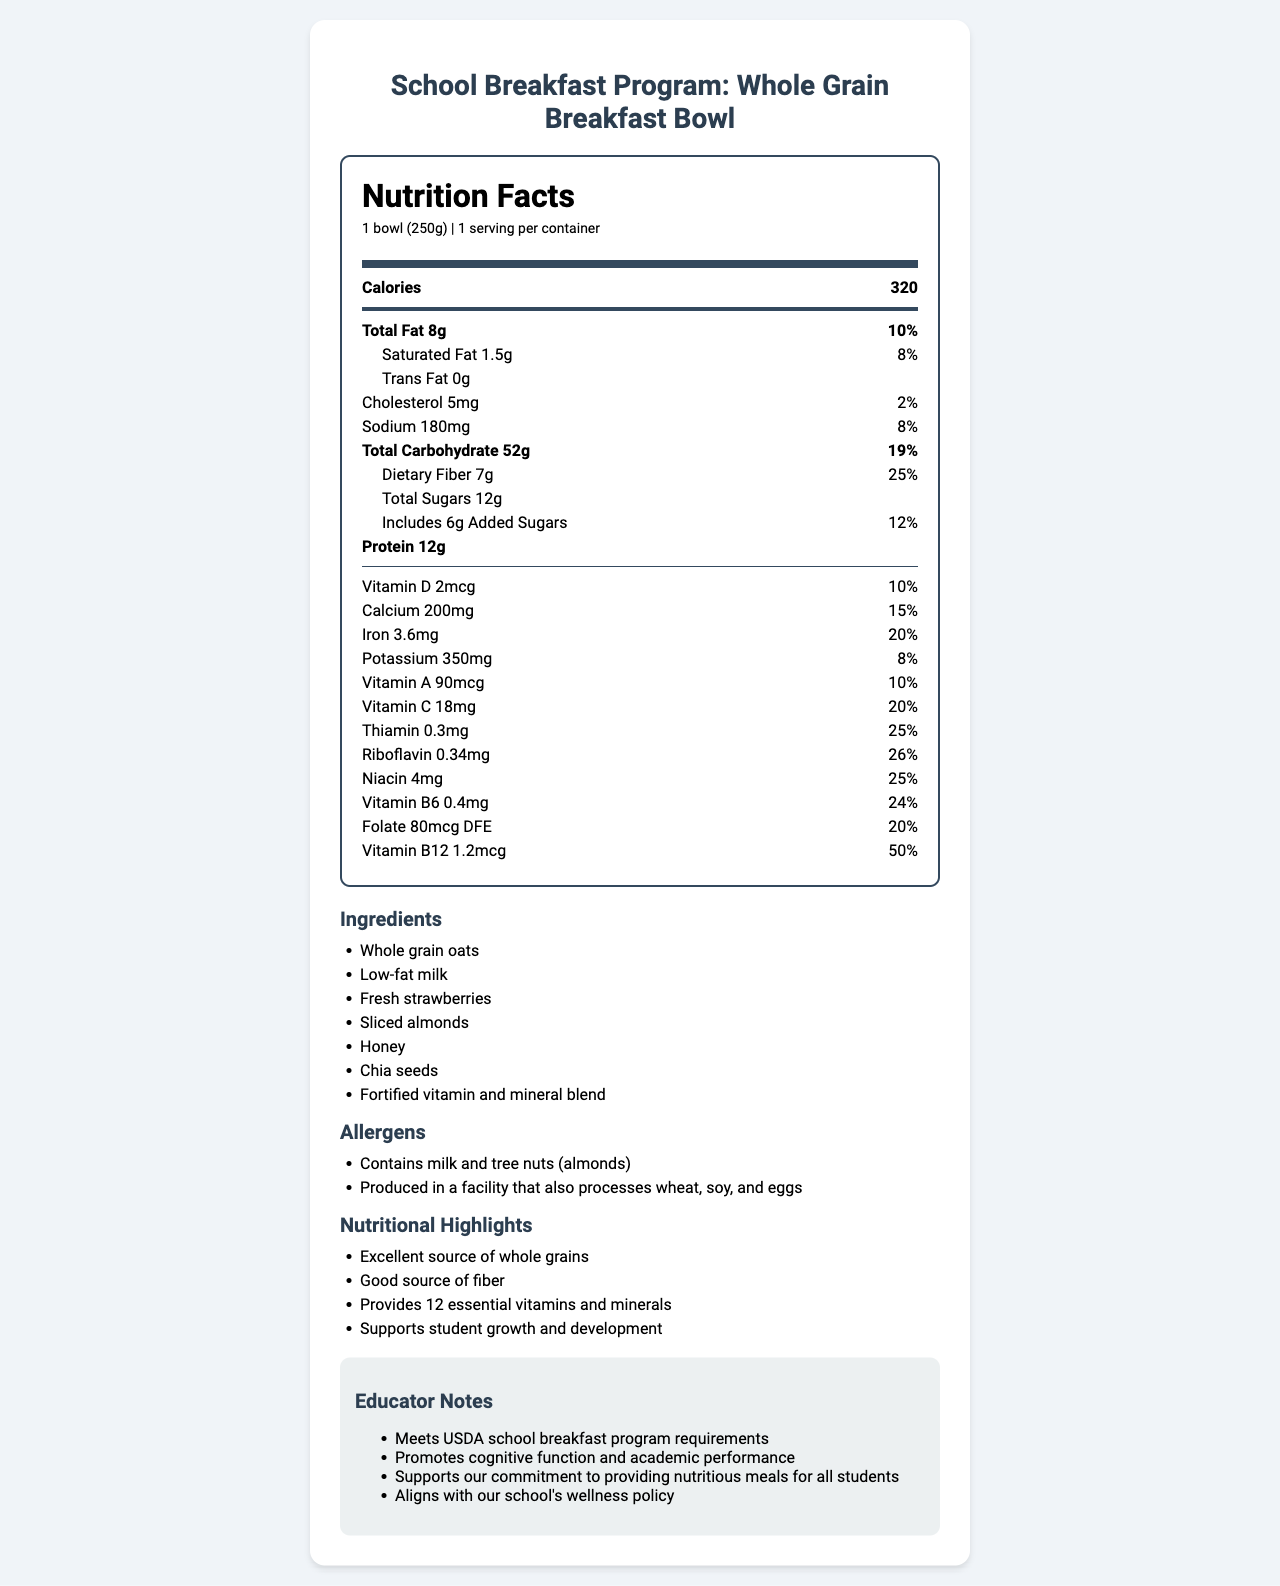what is the serving size of the Whole Grain Breakfast Bowl? The serving size is clearly listed as "1 bowl (250g)".
Answer: 1 bowl (250g) how many calories are in one serving? The document lists the number of calories as 320.
Answer: 320 which ingredient is listed first? The first ingredient listed is "Whole grain oats".
Answer: Whole grain oats what are the two main allergens found in the Whole Grain Breakfast Bowl? The allergens section lists "Contains milk and tree nuts (almonds)".
Answer: Milk and tree nuts (almonds) how much protein does one serving of the Whole Grain Breakfast Bowl contain? The amount of protein per serving is listed as 12g.
Answer: 12g what percentage of the daily value of iron is provided by one serving? The document shows iron at 3.6mg, providing 20% of the daily value.
Answer: 20% which vitamin provides the highest percentage of daily value per serving? Vitamin B12 provides the highest percentage of daily value at 50%.
Answer: Vitamin B12 how much added sugar is in one serving? A. 4g B. 6g C. 8g D. 10g The document lists added sugars as "6g".
Answer: B. 6g which of the following is not an ingredient in the Whole Grain Breakfast Bowl? i. Whole grain oats ii. Low-fat milk iii. Coconut flakes iv. Chia seeds Coconut flakes are not listed among the ingredients.
Answer: iii. Coconut flakes does the Whole Grain Breakfast Bowl support student growth and development? Yes/No The nutritional highlights section mentions "Supports student growth and development".
Answer: Yes summarize the main idea of the document. The document includes serving size, calories, detailed nutritional breakdown, ingredients, allergens, nutritional highlights, and educator notes, emphasizing its nutritional benefits and suitability for the school breakfast program.
Answer: The document provides detailed nutritional information for the Whole Grain Breakfast Bowl, highlighting its ingredients, allergens, and significant nutrient contributions, which support student growth and development. It meets the USDA school breakfast program requirements and aligns with the school's wellness policy. what is the percentage of daily value for potassium? The document lists potassium at 350mg, providing 8% of the daily value.
Answer: 8% how many grams of dietary fiber does one serving contain? The amount of dietary fiber is shown as 7g.
Answer: 7g how is the Whole Grain Breakfast Bowl beneficial for cognitive function? The educator's notes section mentions that it "Promotes cognitive function and academic performance".
Answer: Promotes cognitive function and academic performance can you determine the exact quantity of chia seeds in the breakfast bowl? The document lists chia seeds as an ingredient but does not specify the exact quantity.
Answer: Not enough information 